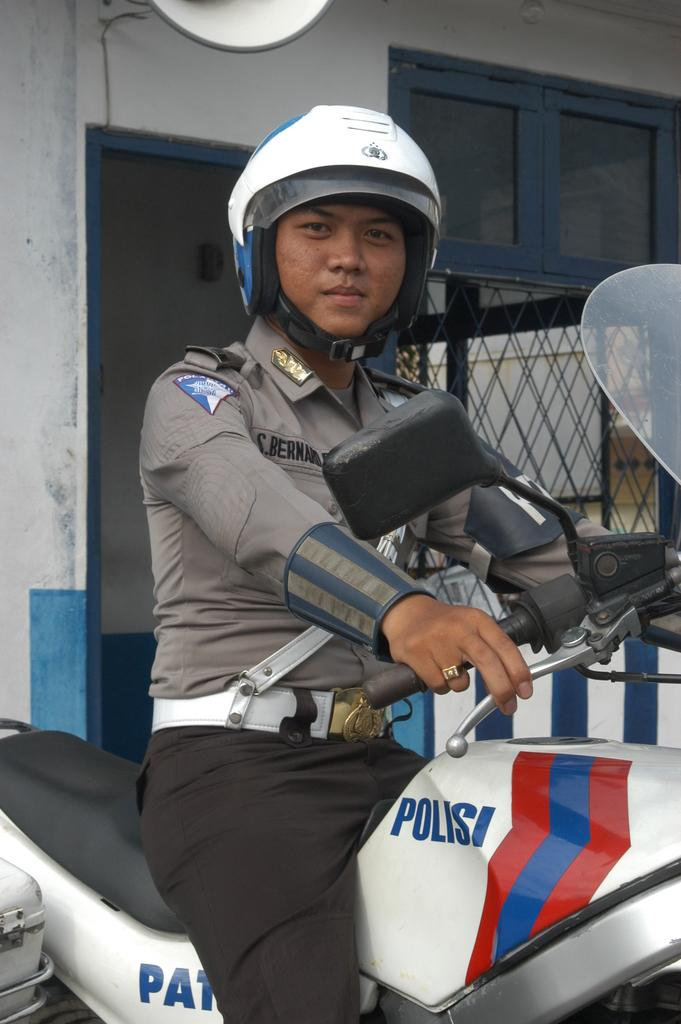What is the main subject of the image? There is a person in the image. What is the person wearing? The person is wearing a uniform. What is the person doing in the image? The person is sitting on a bike. What type of meat can be seen cooking on the boundary in the image? There is no meat or boundary present in the image; it features a person sitting on a bike while wearing a uniform. 